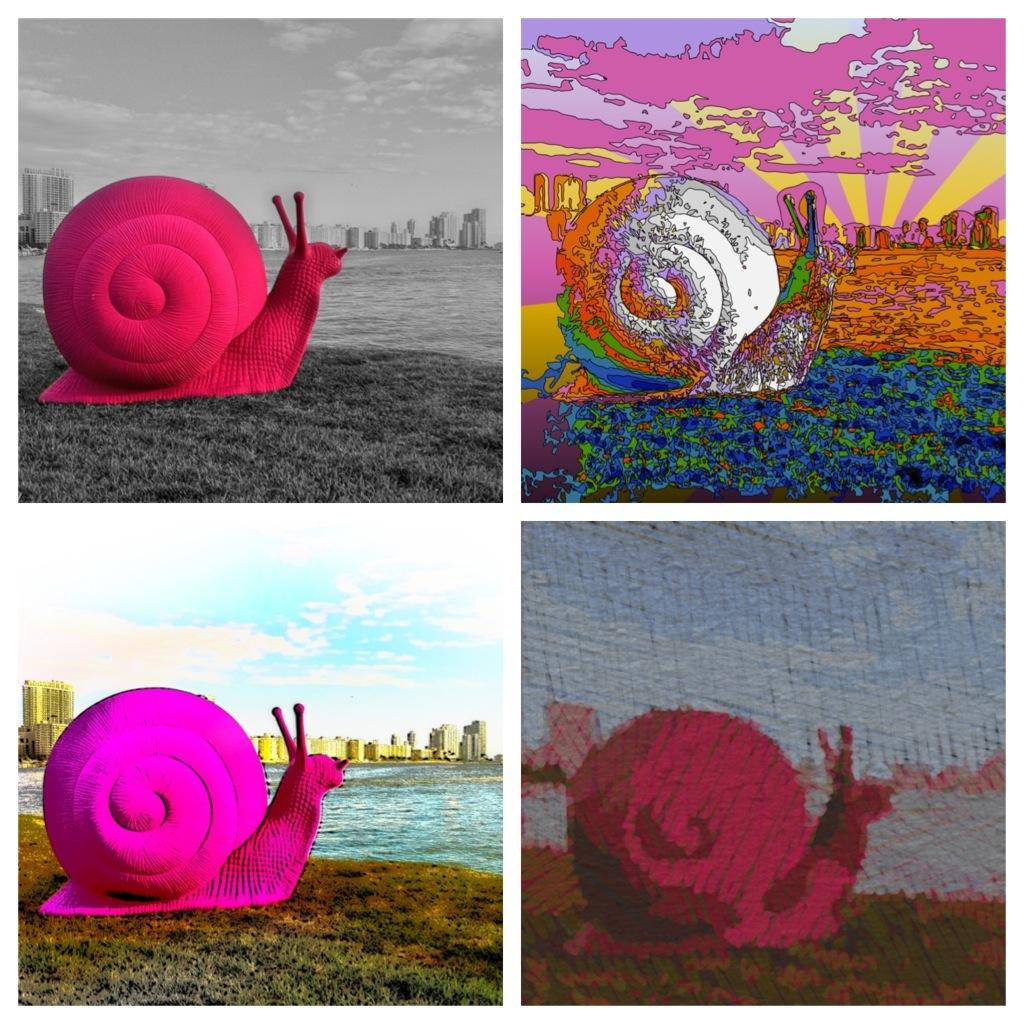What type of artwork is the image? The image is a collage of 4 edited images. What is located in the front of the image? There is a snail in the front of the image. What is in the center of the image? There is water in the center of the image. What can be seen at the back of the image? There are buildings at the back of the image. What is visible at the top of the image? The sky is visible at the top of the image. What color is the orange in the image? There is no orange present in the image; it is a collage of 4 edited images featuring a snail, water, buildings, and the sky. In which direction is the image facing? The image does not have a specific direction, as it is a collage of various subjects and objects. 